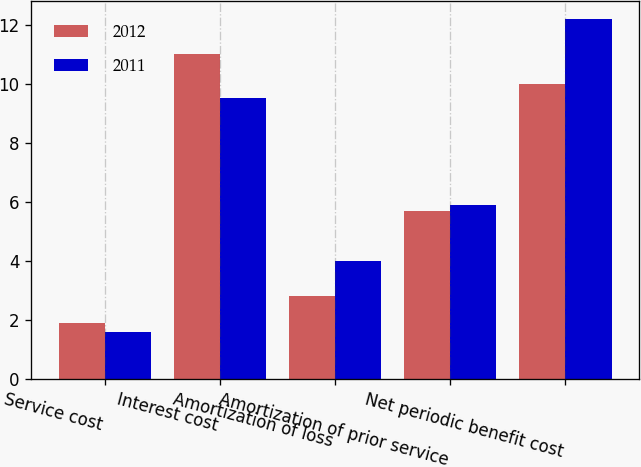Convert chart. <chart><loc_0><loc_0><loc_500><loc_500><stacked_bar_chart><ecel><fcel>Service cost<fcel>Interest cost<fcel>Amortization of loss<fcel>Amortization of prior service<fcel>Net periodic benefit cost<nl><fcel>2012<fcel>1.9<fcel>11<fcel>2.8<fcel>5.7<fcel>10<nl><fcel>2011<fcel>1.6<fcel>9.5<fcel>4<fcel>5.9<fcel>12.2<nl></chart> 